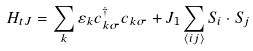<formula> <loc_0><loc_0><loc_500><loc_500>H _ { t J } = \sum _ { k } \varepsilon _ { k } c _ { k \sigma } ^ { \dagger } c _ { k \sigma } + J _ { 1 } \sum _ { \langle i j \rangle } { S } _ { i } \cdot { S } _ { j }</formula> 